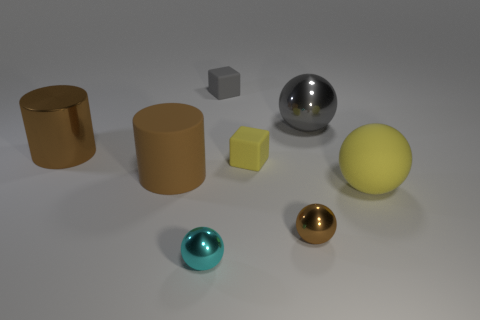Subtract all brown cylinders. How many were subtracted if there are1brown cylinders left? 1 Subtract all metal balls. How many balls are left? 1 Subtract all brown balls. How many balls are left? 3 Add 1 tiny cyan shiny objects. How many objects exist? 9 Subtract all cyan spheres. Subtract all red cubes. How many spheres are left? 3 Subtract all cubes. How many objects are left? 6 Add 3 large rubber objects. How many large rubber objects are left? 5 Add 2 brown cylinders. How many brown cylinders exist? 4 Subtract 1 yellow spheres. How many objects are left? 7 Subtract all brown rubber objects. Subtract all gray metallic objects. How many objects are left? 6 